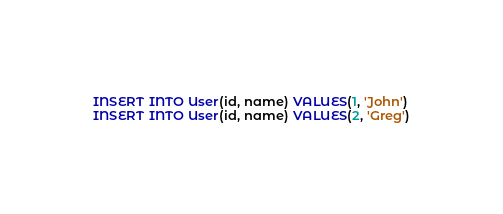<code> <loc_0><loc_0><loc_500><loc_500><_SQL_>INSERT INTO User(id, name) VALUES(1, 'John')
INSERT INTO User(id, name) VALUES(2, 'Greg')
</code> 